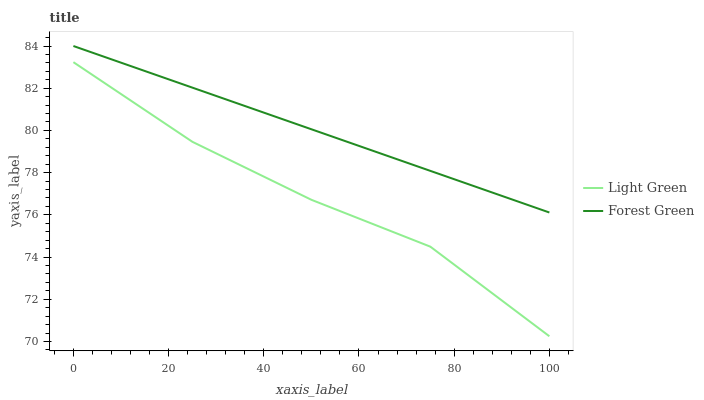Does Light Green have the minimum area under the curve?
Answer yes or no. Yes. Does Forest Green have the maximum area under the curve?
Answer yes or no. Yes. Does Light Green have the maximum area under the curve?
Answer yes or no. No. Is Forest Green the smoothest?
Answer yes or no. Yes. Is Light Green the roughest?
Answer yes or no. Yes. Is Light Green the smoothest?
Answer yes or no. No. Does Light Green have the lowest value?
Answer yes or no. Yes. Does Forest Green have the highest value?
Answer yes or no. Yes. Does Light Green have the highest value?
Answer yes or no. No. Is Light Green less than Forest Green?
Answer yes or no. Yes. Is Forest Green greater than Light Green?
Answer yes or no. Yes. Does Light Green intersect Forest Green?
Answer yes or no. No. 